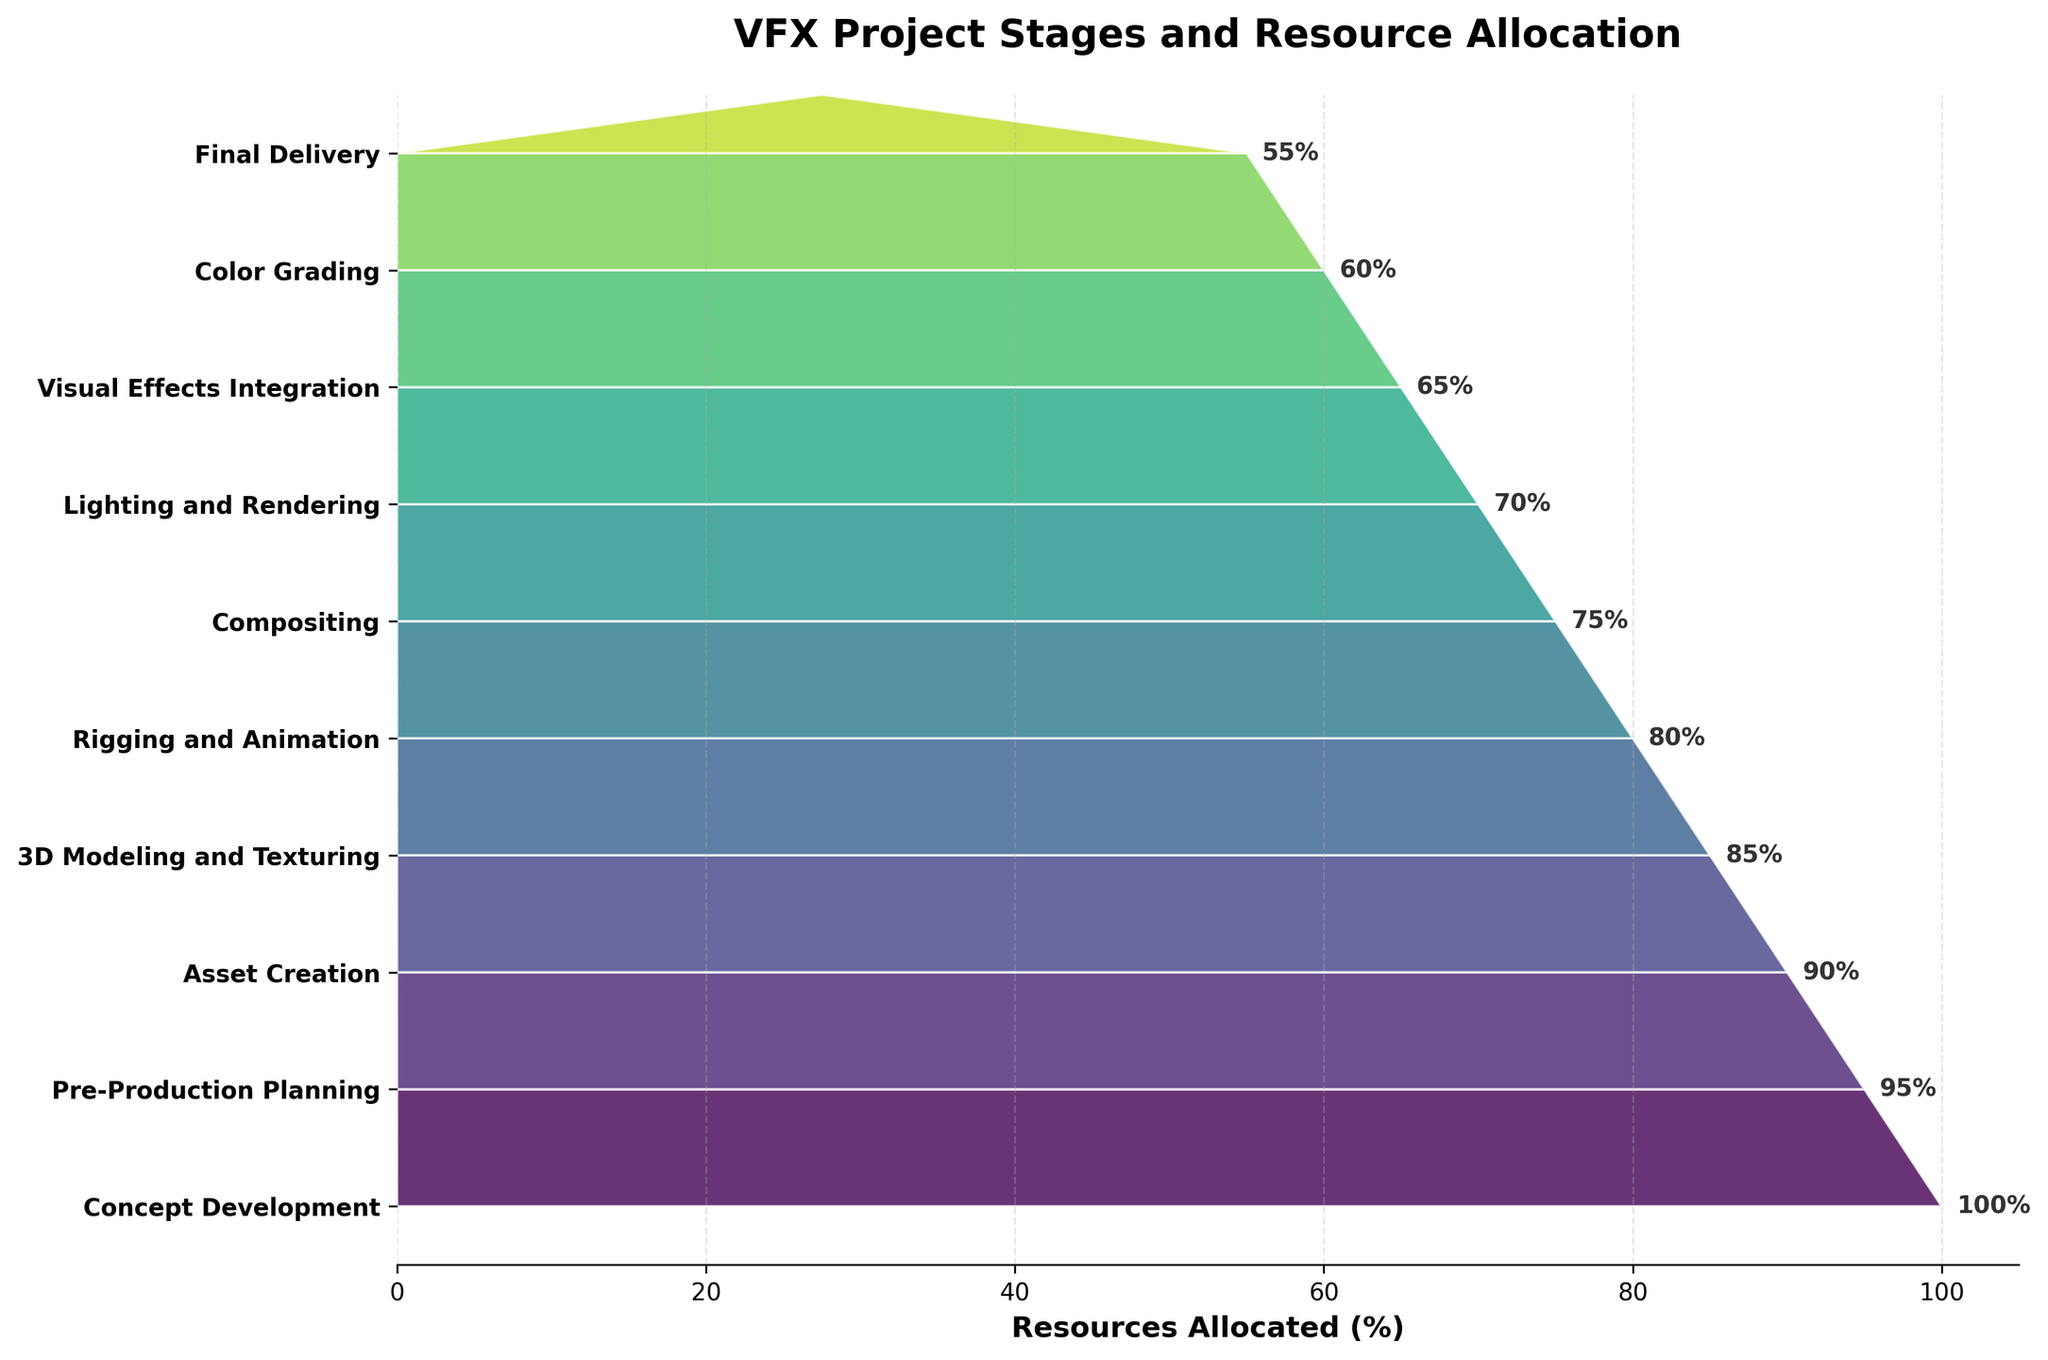What's the title of the chart? The title of the chart can be identified by looking at the top of the figure. It summarizes the main topic represented by the chart. In this case, it states the subject of resource allocation across different stages of a VFX project.
Answer: VFX Project Stages and Resource Allocation How many stages are represented in the chart? By counting the number of distinct stages listed on the y-axis, we can determine the total number of different VFX project stages. Each y-tick label corresponds to a stage.
Answer: 10 Which stage has the highest percentage of resources allocated? The stage with the highest percentage of resources allocated can be identified by examining the length of the funnel segment corresponding to each stage. The longest segment at the top represents the highest allocation.
Answer: Concept Development What is the lowest percentage of resources allocated to a stage? The lowest percentage of resources allocated can be identified by looking at the length of the funnel segment at the bottom of the chart. The shortest segment represents the lowest allocation.
Answer: 55% How much more resources are allocated to 3D Modeling and Texturing compared to Final Delivery? To find the difference in resource allocation between two stages, identify the resource percentages for each stage and subtract the smaller value from the larger one.
Answer: 85% - 55% = 30% Which stages have less than 80% of resources allocated? To determine which stages have less than 80% of resources allocated, look at the percentage of resources next to each stage and identify those with values under 80%.
Answer: Compositing, Lighting and Rendering, Visual Effects Integration, Color Grading, Final Delivery Is there a stage where resource allocation decreases by exactly 5% from the previous stage? To identify such a stage, we need to examine the percentage differences between consecutive stages and find where the difference is exactly 5%.
Answer: Pre-Production Planning to Asset Creation What's the average percentage of resources allocated across all stages? To find the average, sum up the percentages for all stages and divide by the number of stages. The sum is (100 + 95 + 90 + 85 + 80 + 75 + 70 + 65 + 60 + 55) = 775. The average is then 775/10 = 77.5%.
Answer: 77.5% Which stage experiences the highest reduction in resource allocation compared to the previous stage? To find the stage with the highest reduction, we need to calculate the difference in resource allocation between consecutive stages and identify the largest decrease. By examining the differences, the largest drop is from Concept Development to Pre-Production Planning (100% - 95% = 5%).
Answer: Concept Development to Pre-Production Planning 